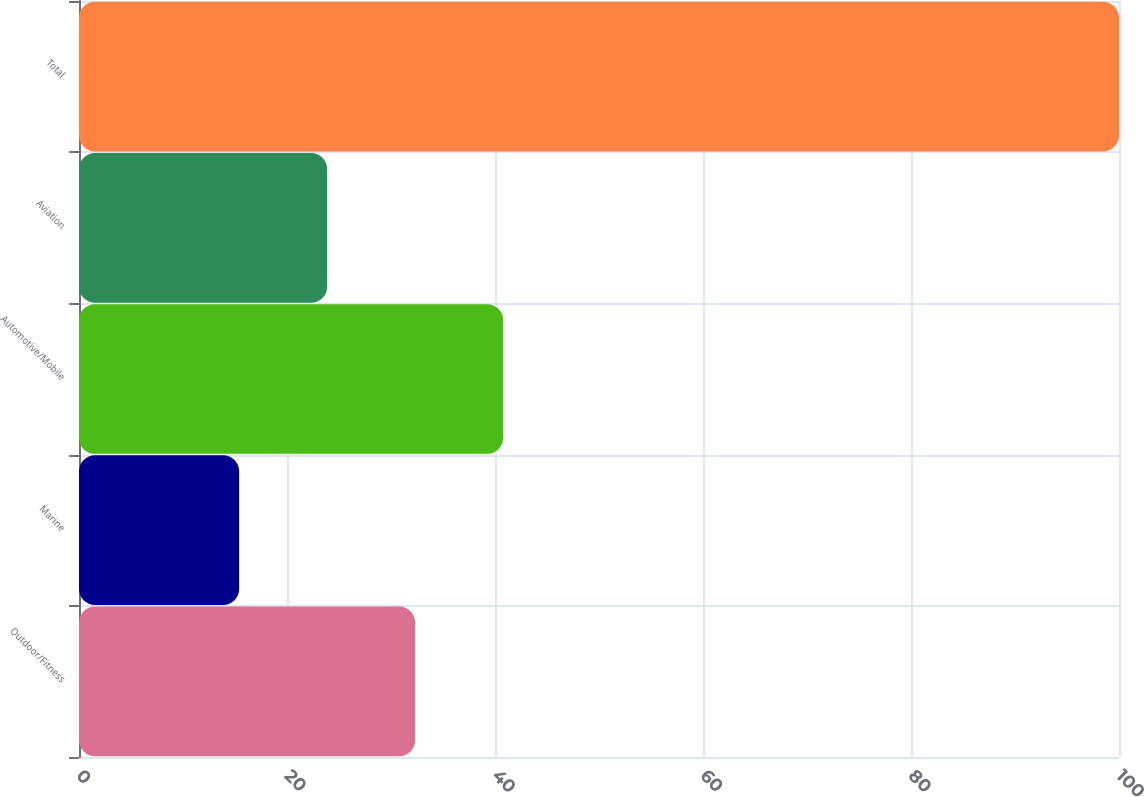Convert chart. <chart><loc_0><loc_0><loc_500><loc_500><bar_chart><fcel>Outdoor/Fitness<fcel>Marine<fcel>Automotive/Mobile<fcel>Aviation<fcel>Total<nl><fcel>32.32<fcel>15.4<fcel>40.78<fcel>23.86<fcel>100<nl></chart> 